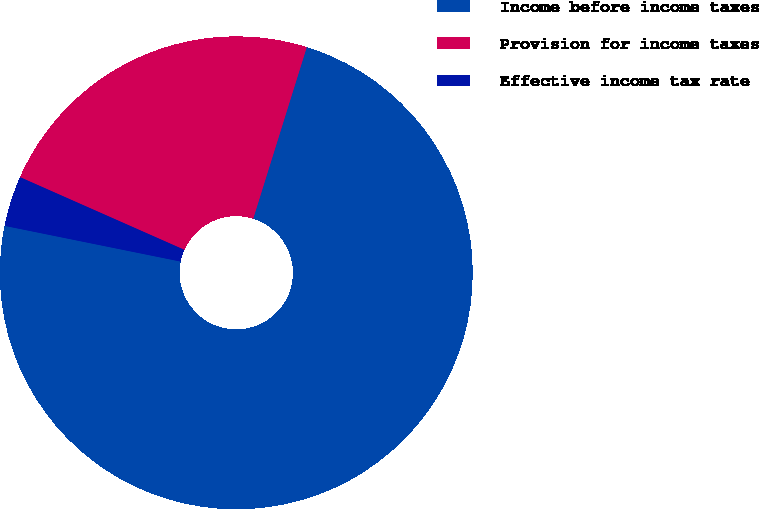Convert chart to OTSL. <chart><loc_0><loc_0><loc_500><loc_500><pie_chart><fcel>Income before income taxes<fcel>Provision for income taxes<fcel>Effective income tax rate<nl><fcel>73.37%<fcel>23.19%<fcel>3.44%<nl></chart> 